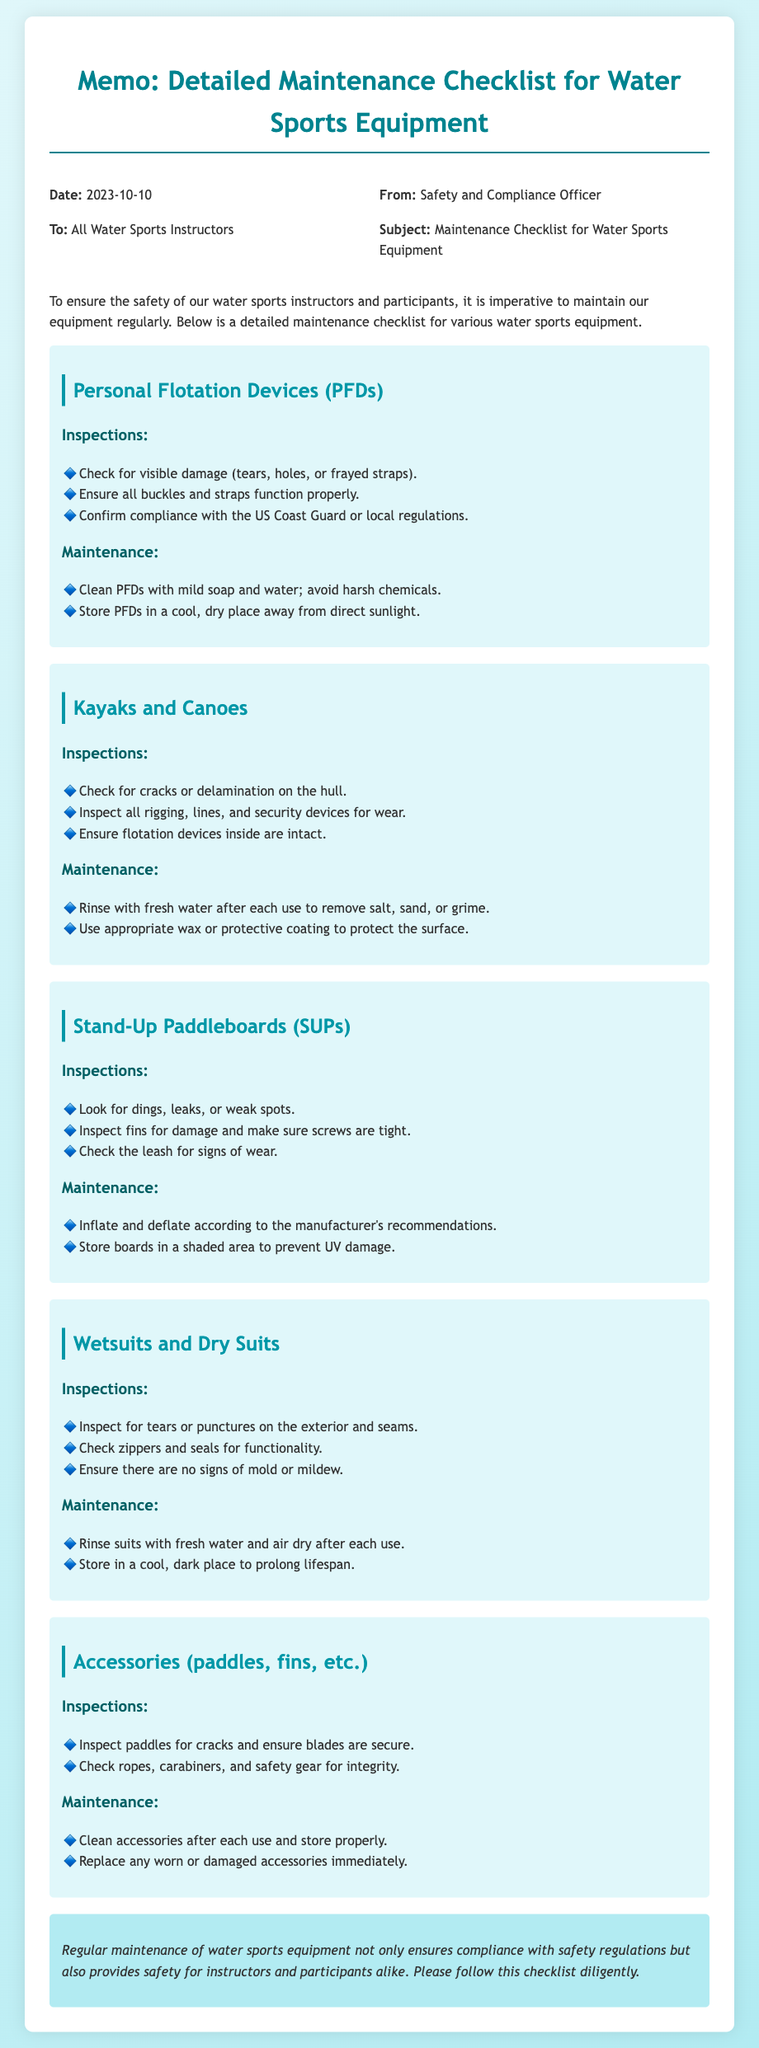What is the date of the memo? The date is clearly stated in the document, which is 2023-10-10.
Answer: 2023-10-10 Who is the memo addressed to? The document specifies that the memo is addressed to "All Water Sports Instructors."
Answer: All Water Sports Instructors What is one maintenance tip for Personal Flotation Devices? Among the tips listed, "Clean PFDs with mild soap and water; avoid harsh chemicals." is provided.
Answer: Clean PFDs with mild soap and water; avoid harsh chemicals How many types of equipment are mentioned in the checklist? The checklist section lists five specific types of water sports equipment.
Answer: Five What should you check for in Stand-Up Paddleboards during inspections? One of the inspection points for SUPs is to "Look for dings, leaks, or weak spots."
Answer: Look for dings, leaks, or weak spots What should accessories be checked for? The memo explicitly mentions to "Inspect paddles for cracks and ensure blades are secure."
Answer: Check for cracks and ensure blades are secure Why is regular maintenance emphasized in the conclusion? The conclusion notes that regular maintenance ensures compliance with safety regulations and safety for all involved.
Answer: Ensures compliance and safety Which items are listed under Wetsuits and Dry Suits maintenance tips? The maintenance tips include "Rinse suits with fresh water and air dry after each use."
Answer: Rinse suits with fresh water and air dry after each use 